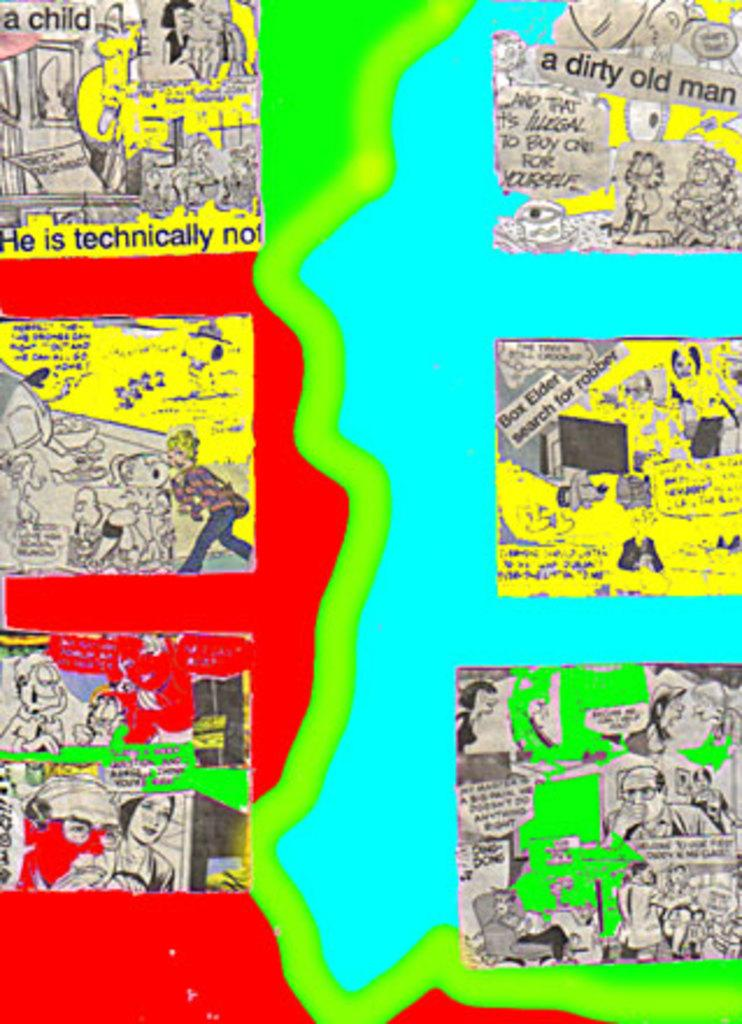What is present in the image that contains multiple sections? There is a poster in the image that contains six frames. What type of content is featured in the frames of the poster? The frames contain cartoons. What type of boat can be seen at the edge of the dress in the image? There is no boat or dress present in the image; it only contains a poster with six frames of cartoons. 